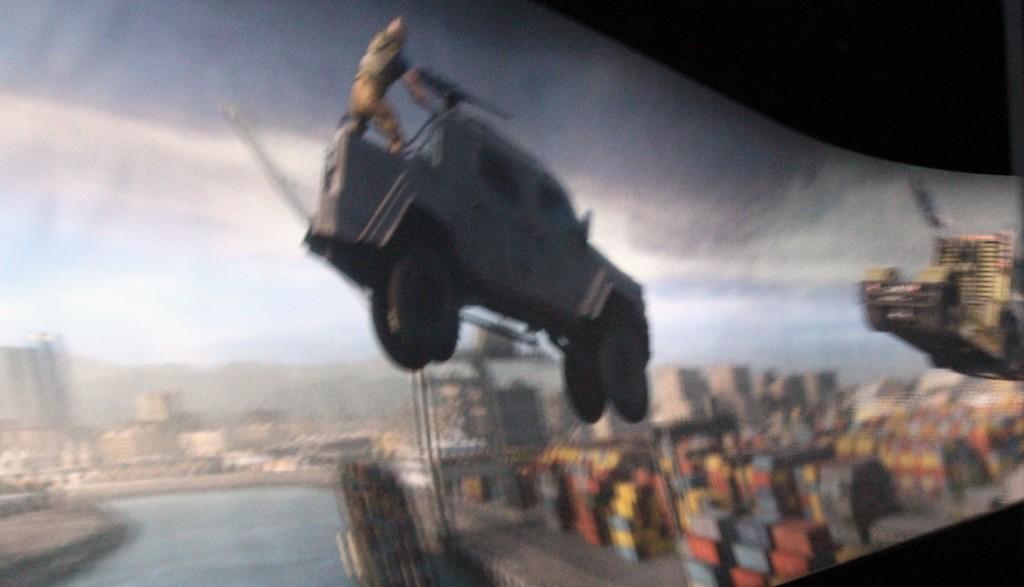How would you summarize this image in a sentence or two? In this image we can see a car is jumping and one man is standing on it. Background of the image buildings are present and one lake is there. 